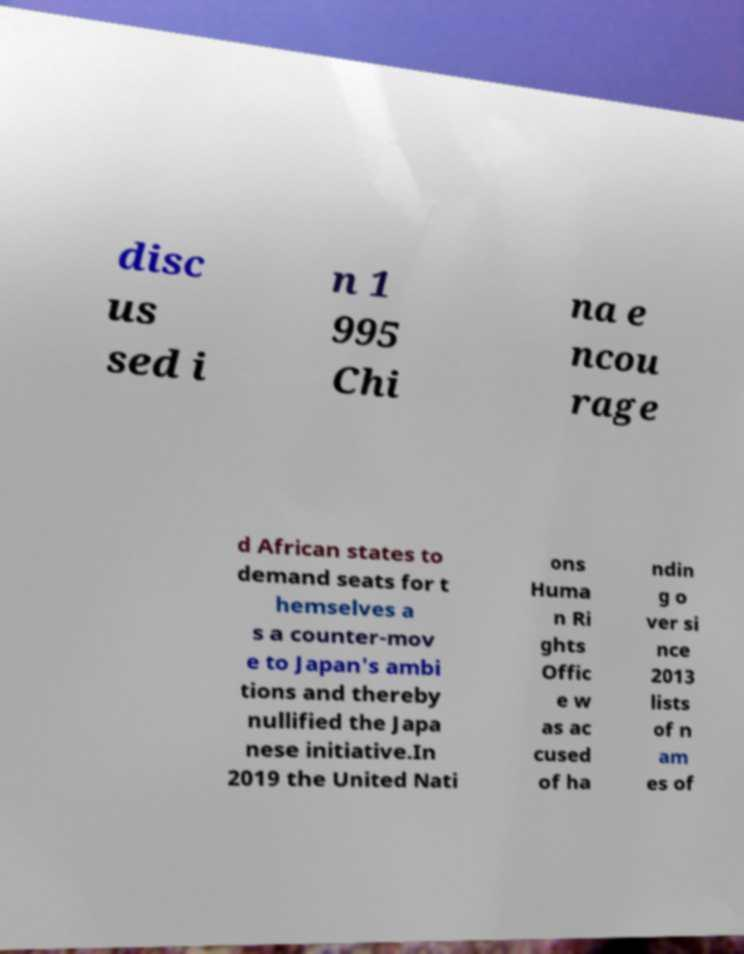For documentation purposes, I need the text within this image transcribed. Could you provide that? disc us sed i n 1 995 Chi na e ncou rage d African states to demand seats for t hemselves a s a counter-mov e to Japan's ambi tions and thereby nullified the Japa nese initiative.In 2019 the United Nati ons Huma n Ri ghts Offic e w as ac cused of ha ndin g o ver si nce 2013 lists of n am es of 